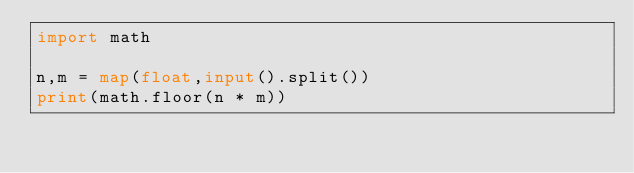<code> <loc_0><loc_0><loc_500><loc_500><_Python_>import math

n,m = map(float,input().split())
print(math.floor(n * m))</code> 